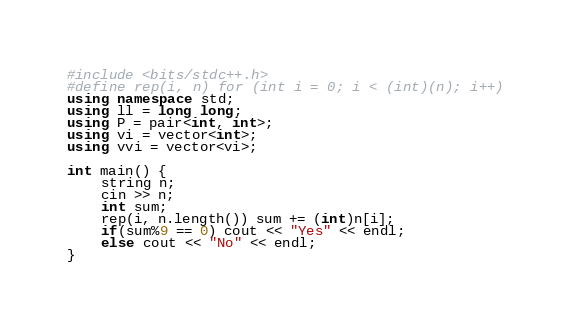Convert code to text. <code><loc_0><loc_0><loc_500><loc_500><_C++_>#include <bits/stdc++.h>
#define rep(i, n) for (int i = 0; i < (int)(n); i++)
using namespace std;
using ll = long long;
using P = pair<int, int>;
using vi = vector<int>;
using vvi = vector<vi>;

int main() {
    string n;
    cin >> n;
    int sum;
    rep(i, n.length()) sum += (int)n[i];
    if(sum%9 == 0) cout << "Yes" << endl;
    else cout << "No" << endl;
}</code> 